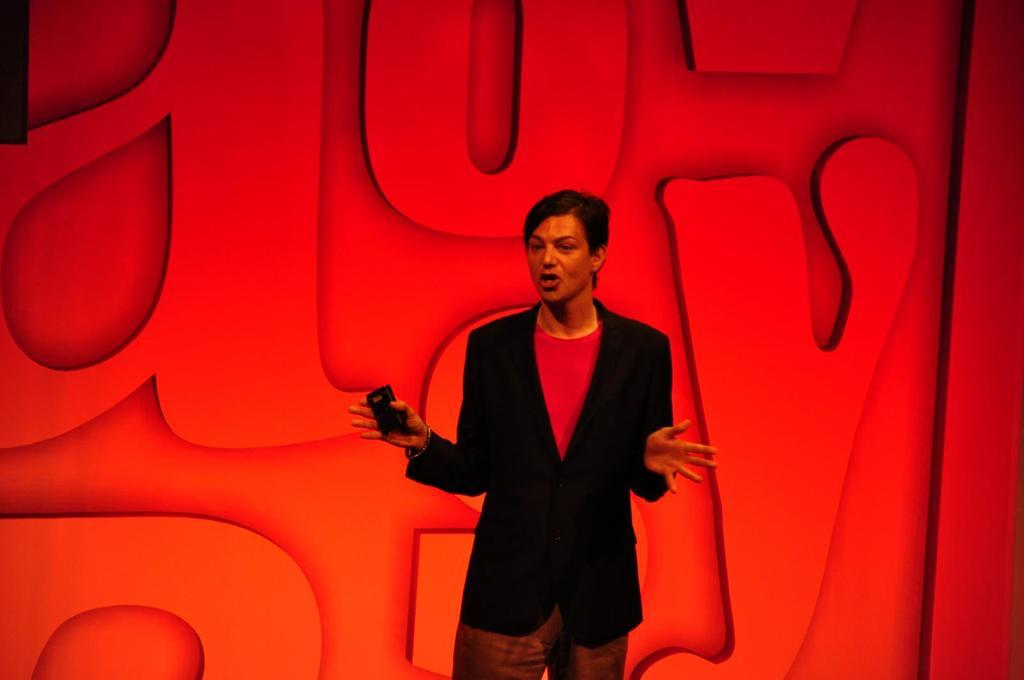What is happening in the image? There is a person in the image who is talking. What is the person holding in the image? The person is holding an object. What can be seen in the background of the image? There is a wall in the background of the image. What is written on the wall? The wall has letters on it. How many kittens are playing with the sweater in the image? There are no kittens or sweaters present in the image. What type of box is visible in the image? There is no box visible in the image. 